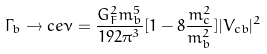<formula> <loc_0><loc_0><loc_500><loc_500>\Gamma _ { b } \to c e \nu = \frac { G ^ { 2 } _ { F } m ^ { 5 } _ { b } } { 1 9 2 \pi ^ { 3 } } [ 1 - 8 \frac { m ^ { 2 } _ { c } } { m ^ { 2 } _ { b } } ] | V _ { c b } | ^ { 2 }</formula> 